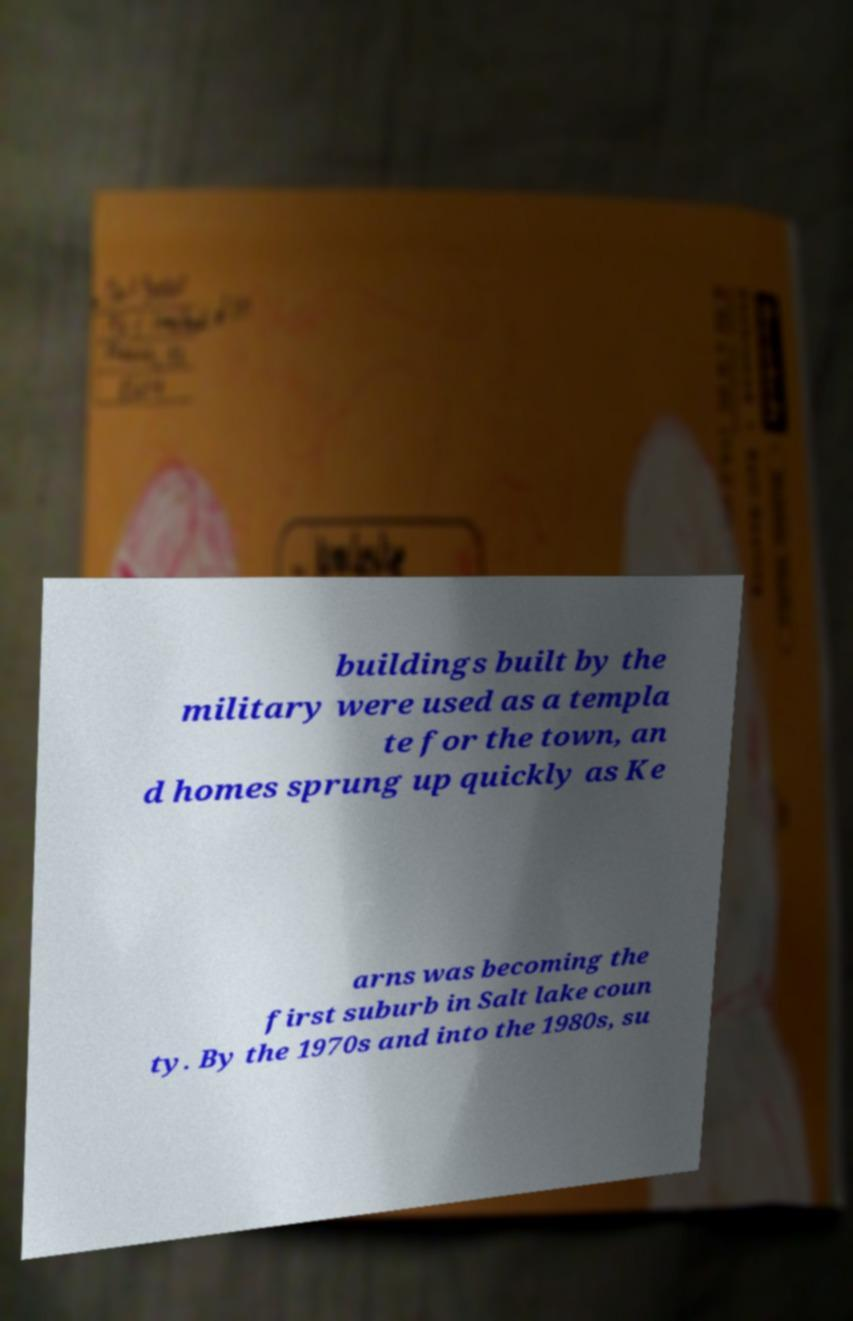Please identify and transcribe the text found in this image. buildings built by the military were used as a templa te for the town, an d homes sprung up quickly as Ke arns was becoming the first suburb in Salt lake coun ty. By the 1970s and into the 1980s, su 